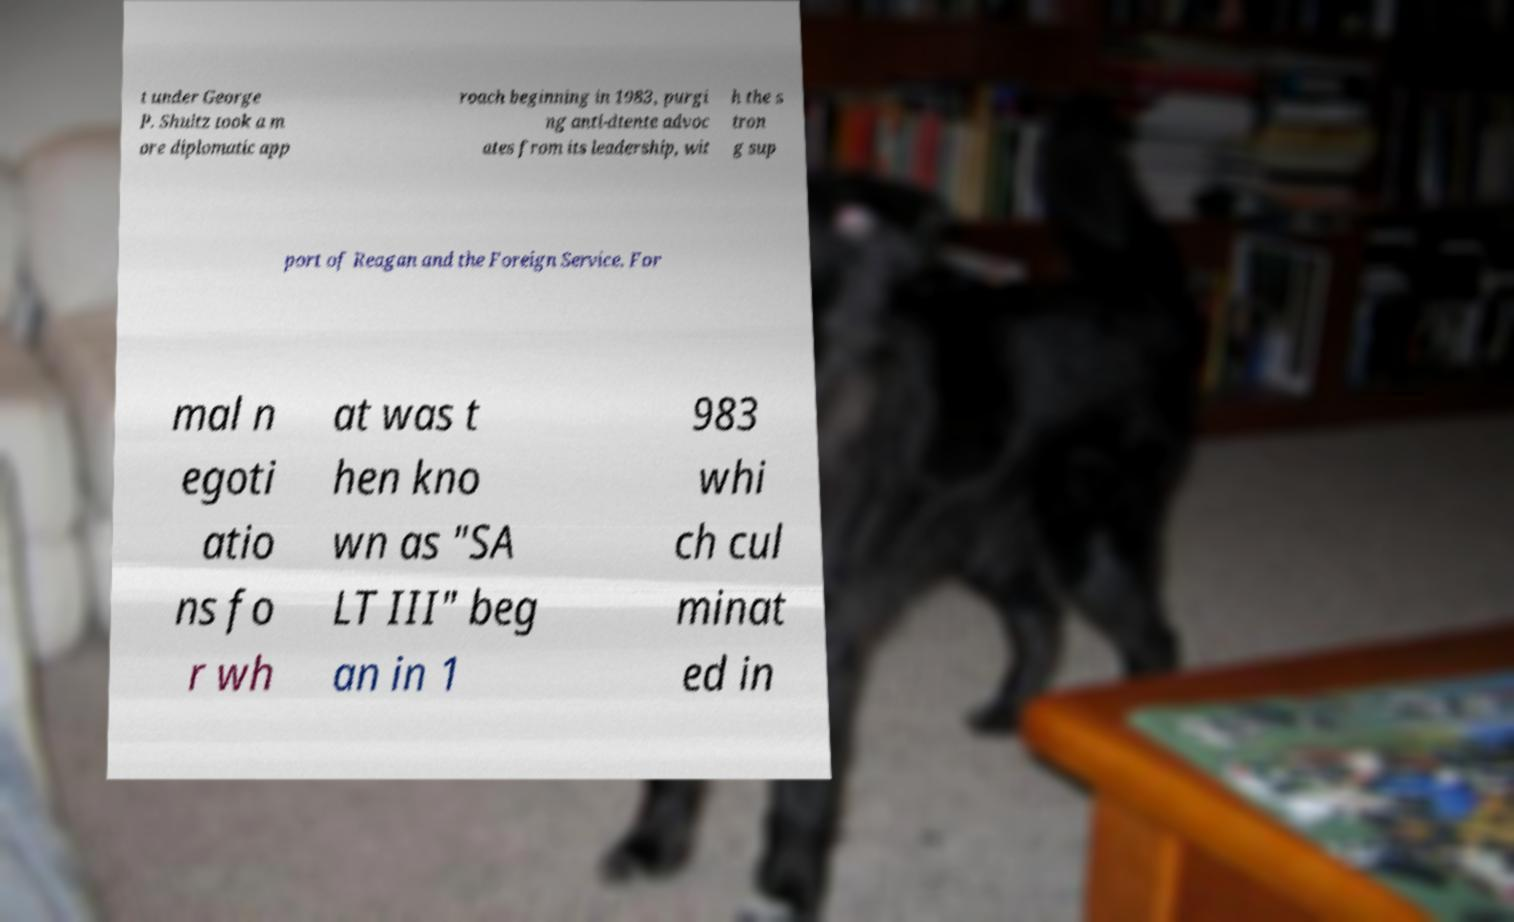Please read and relay the text visible in this image. What does it say? t under George P. Shultz took a m ore diplomatic app roach beginning in 1983, purgi ng anti-dtente advoc ates from its leadership, wit h the s tron g sup port of Reagan and the Foreign Service. For mal n egoti atio ns fo r wh at was t hen kno wn as "SA LT III" beg an in 1 983 whi ch cul minat ed in 